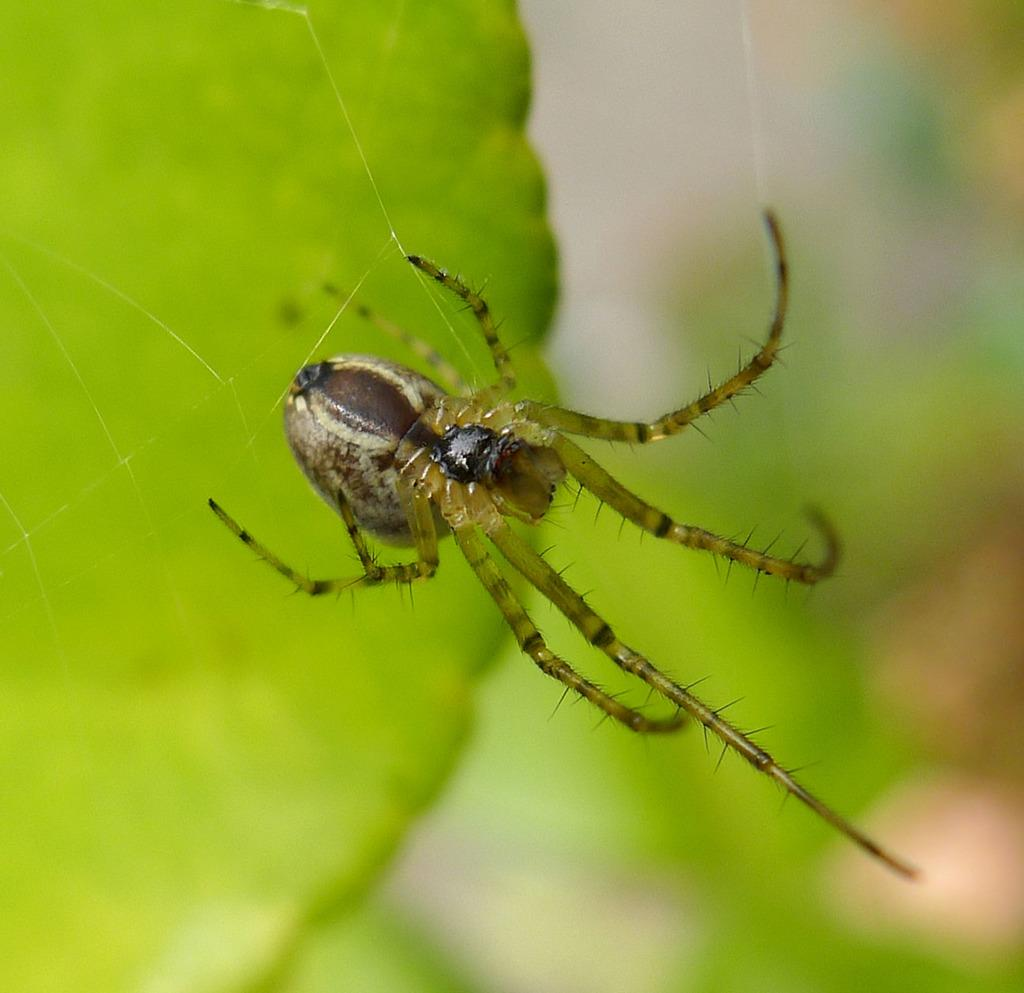What is present on the leaf in the image? There is an insect on the leaf in the image. Can you describe the insect's location in the image? The insect is on a leaf in the image. What can be observed about the background of the image? The background of the image is blurry. What type of cabbage is being stored on the shelf in the image? There is no shelf or cabbage present in the image; it features an insect on a leaf with a blurry background. 